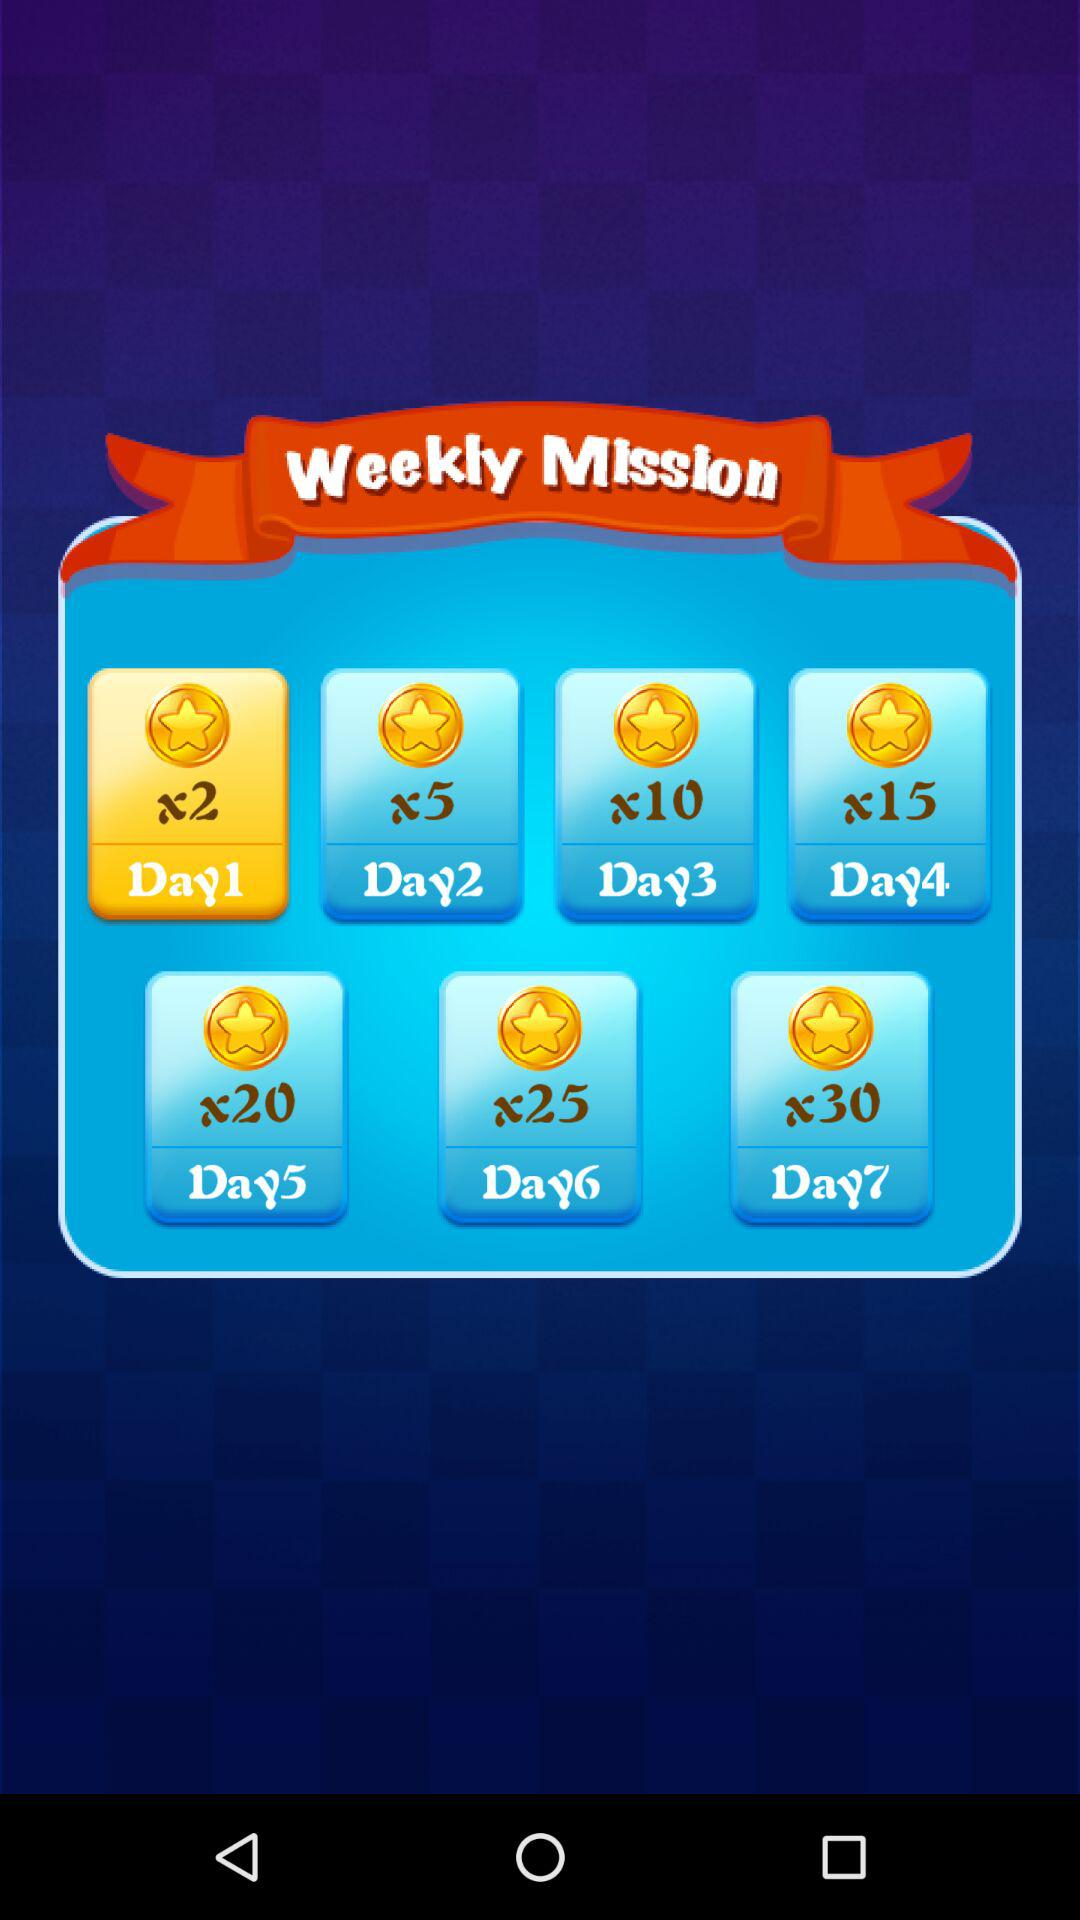What is the day of the weekly mission having "x2"? The day of the weekly mission having "x2" is Day1. 